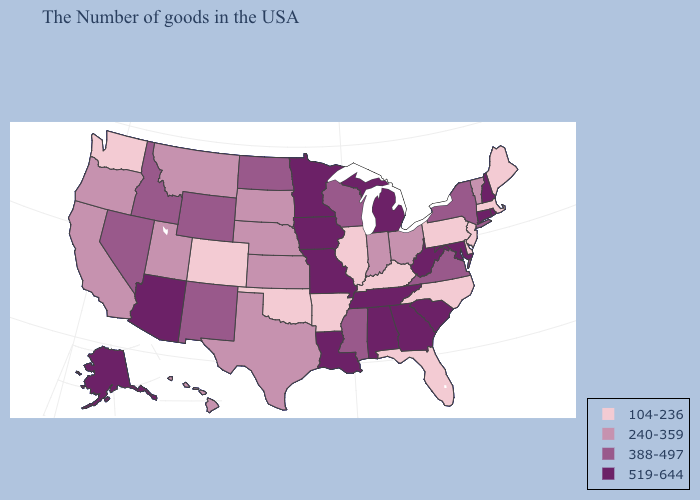Does South Carolina have the lowest value in the USA?
Concise answer only. No. What is the lowest value in states that border Tennessee?
Quick response, please. 104-236. Name the states that have a value in the range 388-497?
Concise answer only. New York, Virginia, Wisconsin, Mississippi, North Dakota, Wyoming, New Mexico, Idaho, Nevada. What is the highest value in the MidWest ?
Answer briefly. 519-644. How many symbols are there in the legend?
Short answer required. 4. What is the value of Georgia?
Answer briefly. 519-644. What is the value of Iowa?
Answer briefly. 519-644. What is the value of Washington?
Quick response, please. 104-236. How many symbols are there in the legend?
Write a very short answer. 4. Name the states that have a value in the range 104-236?
Concise answer only. Maine, Massachusetts, New Jersey, Delaware, Pennsylvania, North Carolina, Florida, Kentucky, Illinois, Arkansas, Oklahoma, Colorado, Washington. What is the lowest value in the USA?
Be succinct. 104-236. What is the value of Indiana?
Quick response, please. 240-359. Name the states that have a value in the range 388-497?
Give a very brief answer. New York, Virginia, Wisconsin, Mississippi, North Dakota, Wyoming, New Mexico, Idaho, Nevada. Name the states that have a value in the range 104-236?
Give a very brief answer. Maine, Massachusetts, New Jersey, Delaware, Pennsylvania, North Carolina, Florida, Kentucky, Illinois, Arkansas, Oklahoma, Colorado, Washington. Name the states that have a value in the range 519-644?
Answer briefly. Rhode Island, New Hampshire, Connecticut, Maryland, South Carolina, West Virginia, Georgia, Michigan, Alabama, Tennessee, Louisiana, Missouri, Minnesota, Iowa, Arizona, Alaska. 